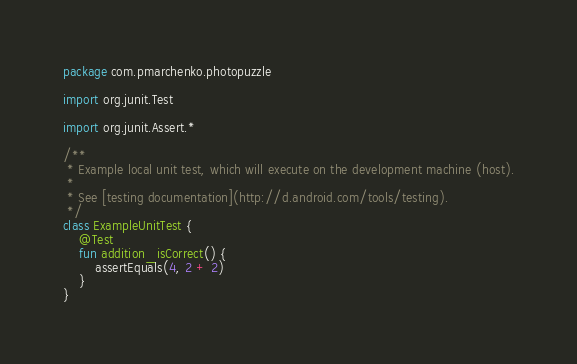Convert code to text. <code><loc_0><loc_0><loc_500><loc_500><_Kotlin_>package com.pmarchenko.photopuzzle

import org.junit.Test

import org.junit.Assert.*

/**
 * Example local unit test, which will execute on the development machine (host).
 *
 * See [testing documentation](http://d.android.com/tools/testing).
 */
class ExampleUnitTest {
    @Test
    fun addition_isCorrect() {
        assertEquals(4, 2 + 2)
    }
}
</code> 